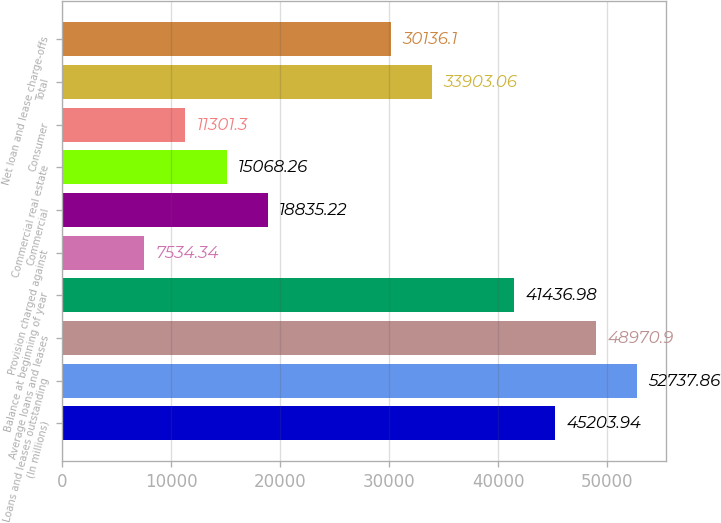<chart> <loc_0><loc_0><loc_500><loc_500><bar_chart><fcel>(In millions)<fcel>Loans and leases outstanding<fcel>Average loans and leases<fcel>Balance at beginning of year<fcel>Provision charged against<fcel>Commercial<fcel>Commercial real estate<fcel>Consumer<fcel>Total<fcel>Net loan and lease charge-offs<nl><fcel>45203.9<fcel>52737.9<fcel>48970.9<fcel>41437<fcel>7534.34<fcel>18835.2<fcel>15068.3<fcel>11301.3<fcel>33903.1<fcel>30136.1<nl></chart> 